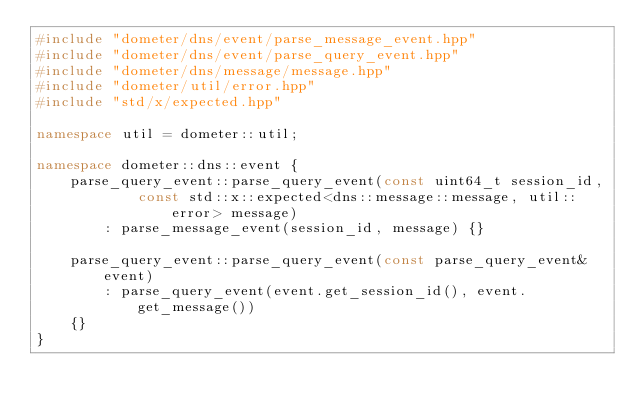Convert code to text. <code><loc_0><loc_0><loc_500><loc_500><_C++_>#include "dometer/dns/event/parse_message_event.hpp"
#include "dometer/dns/event/parse_query_event.hpp"
#include "dometer/dns/message/message.hpp"
#include "dometer/util/error.hpp"
#include "std/x/expected.hpp"

namespace util = dometer::util;

namespace dometer::dns::event {
    parse_query_event::parse_query_event(const uint64_t session_id,
            const std::x::expected<dns::message::message, util::error> message)
        : parse_message_event(session_id, message) {}

    parse_query_event::parse_query_event(const parse_query_event& event)
        : parse_query_event(event.get_session_id(), event.get_message())
    {}
}
</code> 